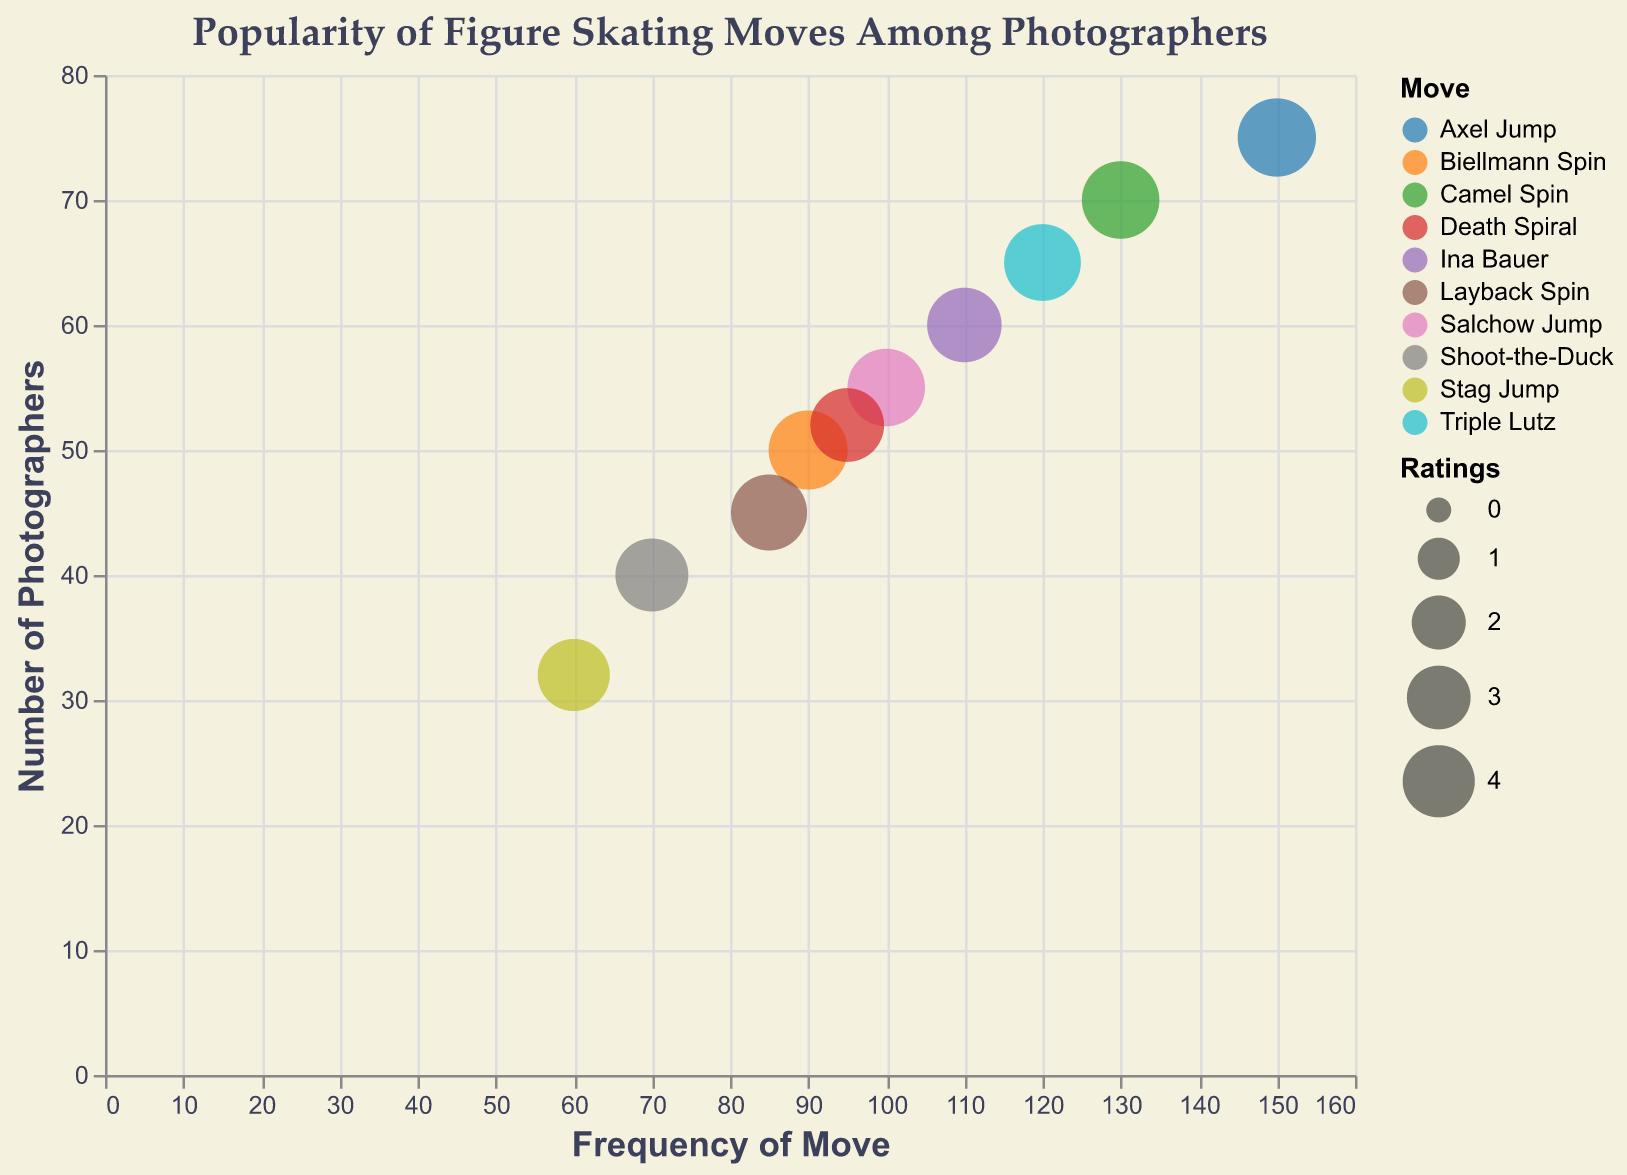What's the title of the bubble chart? The title is displayed at the top of the bubble chart and reads "Popularity of Figure Skating Moves Among Photographers".
Answer: Popularity of Figure Skating Moves Among Photographers How many different figure skating moves are displayed in the chart? Each bubble represents a different figure skating move, and there are 10 bubbles as shown by the "Move" labels in the tooltip.
Answer: 10 Which figure skating move has the highest frequency? By looking at the x-axis and the positioning of the bubbles, the "Axel Jump" is the furthest to the right, indicating it has the highest frequency of 150.
Answer: Axel Jump Which figure skating move has the highest number of photographers capturing it? The "Axel Jump" move is highest on the y-axis indicating it has the highest number of photographers, which is 75.
Answer: Axel Jump What are the frequencies of "Triple Lutz" and "Biellmann Spin" and how do they compare? The x-position of the "Triple Lutz" bubble indicates a frequency of 120, while the "Biellmann Spin" has a frequency of 90. Thus, "Triple Lutz" has a higher frequency.
Answer: Triple Lutz: 120, Biellmann Spin: 90 Among "Salchow Jump", "Camel Spin", and "Ina Bauer", which has the highest rating? "Camel Spin" and "Salchow Jump" both have a rating of 4.7, while "Ina Bauer" has a rating of 4.3, so "Camel Spin" and "Salchow Jump" have the highest rating.
Answer: Camel Spin, Salchow Jump How does the size of the "Stag Jump" bubble compare to others? The size of the bubble represents the rating; "Stag Jump" has a smaller bubble size indicating a lower rating of 4.0 compared to many others which have higher ratings.
Answer: Smaller Which move is positioned closest to the origin of the axes? The "Stag Jump" has the lowest frequency (60) and lowest number of photographers (32) placing its bubble nearest to the origin.
Answer: Stag Jump Which move has the smallest number of photographers capturing it, and what is its rating? The "Stag Jump" has the fewest number of photographers at 32, and its rating is 4.0.
Answer: Stag Jump, 4.0 How many moves have a frequency greater than 100? By examining the x-axis, five moves have a frequency greater than 100: Axel Jump (150), Camel Spin (130), Triple Lutz (120), Ina Bauer (110), and Salchow Jump (100).
Answer: 5 